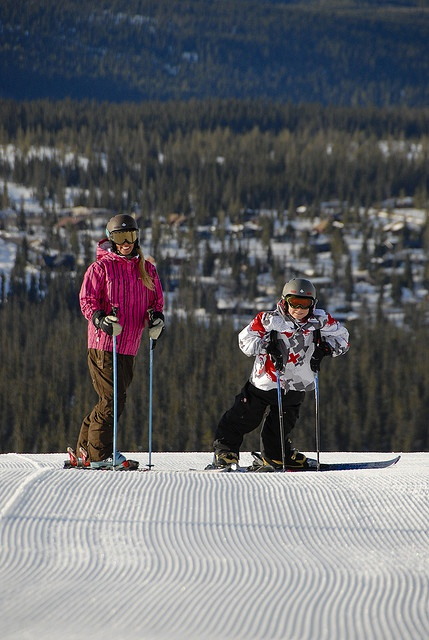Describe the objects in this image and their specific colors. I can see people in black, maroon, and purple tones, people in black, darkgray, gray, and lightgray tones, skis in black, gray, white, and navy tones, and skis in black, lightgray, gray, and darkgray tones in this image. 